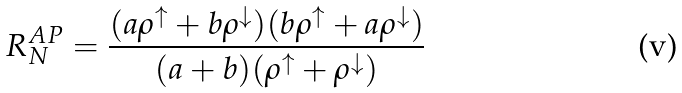Convert formula to latex. <formula><loc_0><loc_0><loc_500><loc_500>R _ { N } ^ { A P } = \frac { ( a \rho ^ { \uparrow } + b \rho ^ { \downarrow } ) ( b \rho ^ { \uparrow } + a \rho ^ { \downarrow } ) } { ( a + b ) ( \rho ^ { \uparrow } + \rho ^ { \downarrow } ) }</formula> 